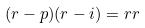<formula> <loc_0><loc_0><loc_500><loc_500>( r - p ) ( r - i ) = r r</formula> 